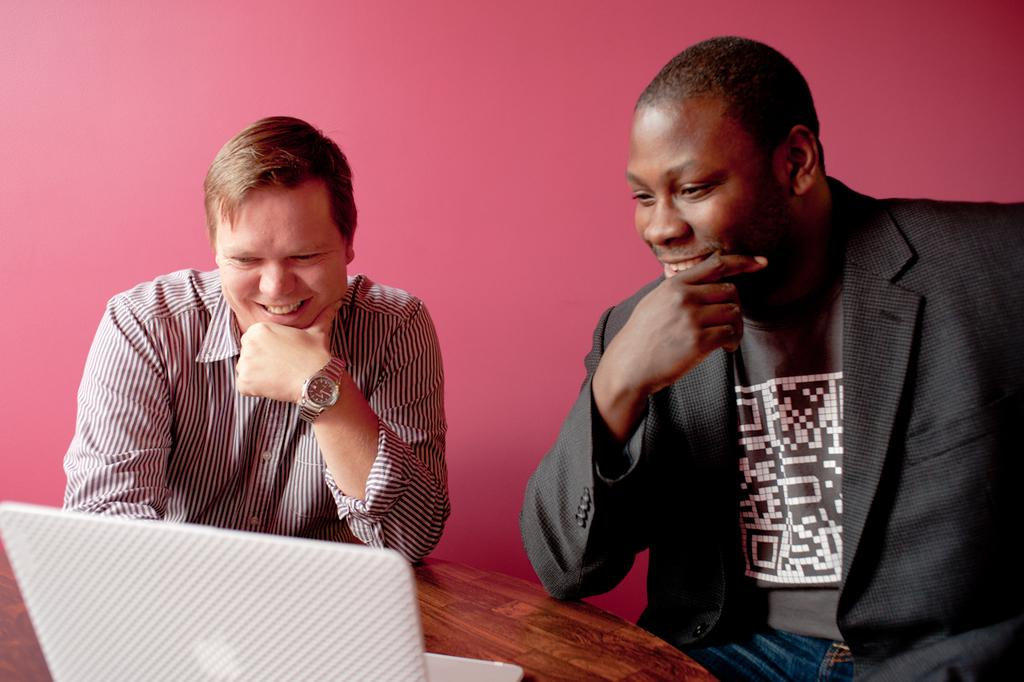How many people are present in the image? There are two persons in the image. What electronic device can be seen in the image? There is a laptop in the image. What type of object made of wood is visible in the image? There is a wooden object in the image. What is visible in the background of the image? There is a wall in the background of the image. Can you tell me how many visitors are present in the image? There is no mention of visitors in the image, only two persons. What type of comb is being used by the persons in the image? There is no comb present in the image. 